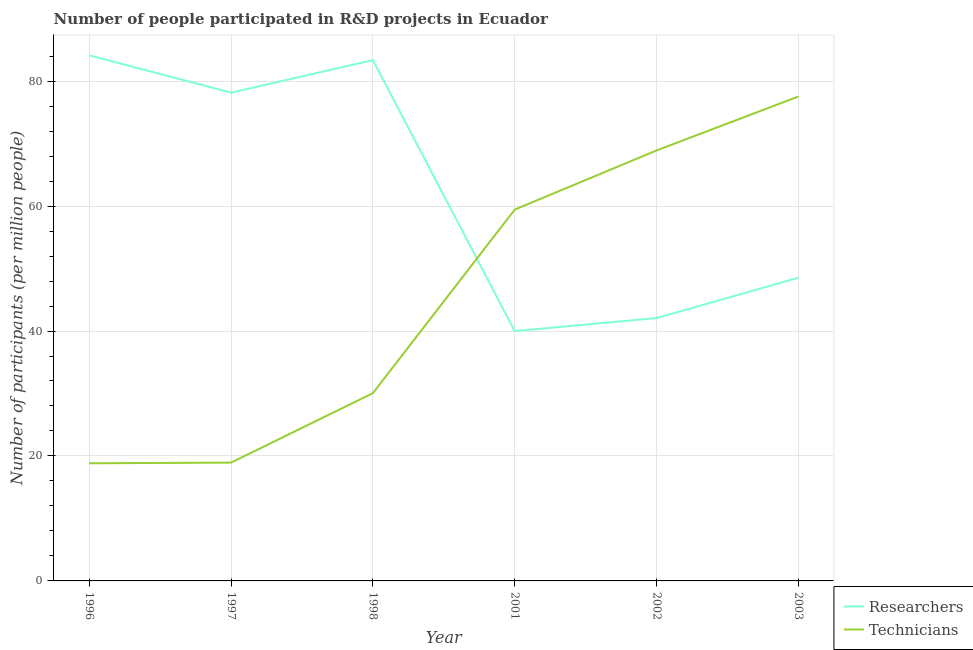How many different coloured lines are there?
Your response must be concise. 2. Does the line corresponding to number of technicians intersect with the line corresponding to number of researchers?
Provide a short and direct response. Yes. What is the number of technicians in 2001?
Ensure brevity in your answer.  59.44. Across all years, what is the maximum number of technicians?
Provide a succinct answer. 77.54. Across all years, what is the minimum number of technicians?
Offer a very short reply. 18.83. In which year was the number of researchers maximum?
Offer a terse response. 1996. In which year was the number of technicians minimum?
Make the answer very short. 1996. What is the total number of researchers in the graph?
Your response must be concise. 376.25. What is the difference between the number of researchers in 1998 and that in 2001?
Provide a succinct answer. 43.37. What is the difference between the number of technicians in 2002 and the number of researchers in 1998?
Your answer should be compact. -14.45. What is the average number of researchers per year?
Your answer should be compact. 62.71. In the year 1998, what is the difference between the number of researchers and number of technicians?
Offer a terse response. 53.31. What is the ratio of the number of technicians in 1996 to that in 2003?
Provide a succinct answer. 0.24. Is the number of technicians in 1996 less than that in 2003?
Offer a terse response. Yes. What is the difference between the highest and the second highest number of researchers?
Make the answer very short. 0.77. What is the difference between the highest and the lowest number of researchers?
Make the answer very short. 44.14. Does the number of researchers monotonically increase over the years?
Provide a short and direct response. No. How many lines are there?
Your answer should be very brief. 2. How many years are there in the graph?
Ensure brevity in your answer.  6. What is the difference between two consecutive major ticks on the Y-axis?
Offer a very short reply. 20. Are the values on the major ticks of Y-axis written in scientific E-notation?
Keep it short and to the point. No. Does the graph contain grids?
Provide a short and direct response. Yes. Where does the legend appear in the graph?
Ensure brevity in your answer.  Bottom right. How are the legend labels stacked?
Your response must be concise. Vertical. What is the title of the graph?
Provide a short and direct response. Number of people participated in R&D projects in Ecuador. What is the label or title of the Y-axis?
Make the answer very short. Number of participants (per million people). What is the Number of participants (per million people) in Researchers in 1996?
Ensure brevity in your answer.  84.14. What is the Number of participants (per million people) in Technicians in 1996?
Offer a terse response. 18.83. What is the Number of participants (per million people) of Researchers in 1997?
Keep it short and to the point. 78.16. What is the Number of participants (per million people) of Technicians in 1997?
Keep it short and to the point. 18.94. What is the Number of participants (per million people) of Researchers in 1998?
Ensure brevity in your answer.  83.36. What is the Number of participants (per million people) of Technicians in 1998?
Your answer should be very brief. 30.05. What is the Number of participants (per million people) in Researchers in 2001?
Provide a short and direct response. 39.99. What is the Number of participants (per million people) in Technicians in 2001?
Provide a short and direct response. 59.44. What is the Number of participants (per million people) in Researchers in 2002?
Your response must be concise. 42.07. What is the Number of participants (per million people) in Technicians in 2002?
Offer a terse response. 68.91. What is the Number of participants (per million people) in Researchers in 2003?
Make the answer very short. 48.53. What is the Number of participants (per million people) of Technicians in 2003?
Your answer should be very brief. 77.54. Across all years, what is the maximum Number of participants (per million people) of Researchers?
Offer a very short reply. 84.14. Across all years, what is the maximum Number of participants (per million people) of Technicians?
Provide a succinct answer. 77.54. Across all years, what is the minimum Number of participants (per million people) in Researchers?
Offer a very short reply. 39.99. Across all years, what is the minimum Number of participants (per million people) of Technicians?
Your answer should be compact. 18.83. What is the total Number of participants (per million people) of Researchers in the graph?
Offer a very short reply. 376.25. What is the total Number of participants (per million people) of Technicians in the graph?
Provide a short and direct response. 273.7. What is the difference between the Number of participants (per million people) in Researchers in 1996 and that in 1997?
Your answer should be very brief. 5.98. What is the difference between the Number of participants (per million people) in Technicians in 1996 and that in 1997?
Your answer should be compact. -0.11. What is the difference between the Number of participants (per million people) in Researchers in 1996 and that in 1998?
Your response must be concise. 0.77. What is the difference between the Number of participants (per million people) of Technicians in 1996 and that in 1998?
Your answer should be compact. -11.22. What is the difference between the Number of participants (per million people) of Researchers in 1996 and that in 2001?
Your answer should be compact. 44.14. What is the difference between the Number of participants (per million people) of Technicians in 1996 and that in 2001?
Ensure brevity in your answer.  -40.61. What is the difference between the Number of participants (per million people) in Researchers in 1996 and that in 2002?
Make the answer very short. 42.06. What is the difference between the Number of participants (per million people) in Technicians in 1996 and that in 2002?
Keep it short and to the point. -50.08. What is the difference between the Number of participants (per million people) in Researchers in 1996 and that in 2003?
Your answer should be compact. 35.6. What is the difference between the Number of participants (per million people) of Technicians in 1996 and that in 2003?
Provide a succinct answer. -58.71. What is the difference between the Number of participants (per million people) in Researchers in 1997 and that in 1998?
Ensure brevity in your answer.  -5.21. What is the difference between the Number of participants (per million people) in Technicians in 1997 and that in 1998?
Offer a terse response. -11.12. What is the difference between the Number of participants (per million people) in Researchers in 1997 and that in 2001?
Make the answer very short. 38.16. What is the difference between the Number of participants (per million people) in Technicians in 1997 and that in 2001?
Offer a very short reply. -40.5. What is the difference between the Number of participants (per million people) of Researchers in 1997 and that in 2002?
Ensure brevity in your answer.  36.08. What is the difference between the Number of participants (per million people) of Technicians in 1997 and that in 2002?
Offer a very short reply. -49.97. What is the difference between the Number of participants (per million people) of Researchers in 1997 and that in 2003?
Your response must be concise. 29.62. What is the difference between the Number of participants (per million people) of Technicians in 1997 and that in 2003?
Ensure brevity in your answer.  -58.6. What is the difference between the Number of participants (per million people) in Researchers in 1998 and that in 2001?
Offer a terse response. 43.37. What is the difference between the Number of participants (per million people) of Technicians in 1998 and that in 2001?
Make the answer very short. -29.38. What is the difference between the Number of participants (per million people) in Researchers in 1998 and that in 2002?
Make the answer very short. 41.29. What is the difference between the Number of participants (per million people) in Technicians in 1998 and that in 2002?
Offer a very short reply. -38.85. What is the difference between the Number of participants (per million people) of Researchers in 1998 and that in 2003?
Provide a short and direct response. 34.83. What is the difference between the Number of participants (per million people) of Technicians in 1998 and that in 2003?
Give a very brief answer. -47.49. What is the difference between the Number of participants (per million people) of Researchers in 2001 and that in 2002?
Ensure brevity in your answer.  -2.08. What is the difference between the Number of participants (per million people) in Technicians in 2001 and that in 2002?
Keep it short and to the point. -9.47. What is the difference between the Number of participants (per million people) of Researchers in 2001 and that in 2003?
Offer a terse response. -8.54. What is the difference between the Number of participants (per million people) of Technicians in 2001 and that in 2003?
Your response must be concise. -18.1. What is the difference between the Number of participants (per million people) of Researchers in 2002 and that in 2003?
Your answer should be compact. -6.46. What is the difference between the Number of participants (per million people) of Technicians in 2002 and that in 2003?
Provide a succinct answer. -8.63. What is the difference between the Number of participants (per million people) in Researchers in 1996 and the Number of participants (per million people) in Technicians in 1997?
Provide a succinct answer. 65.2. What is the difference between the Number of participants (per million people) in Researchers in 1996 and the Number of participants (per million people) in Technicians in 1998?
Give a very brief answer. 54.08. What is the difference between the Number of participants (per million people) of Researchers in 1996 and the Number of participants (per million people) of Technicians in 2001?
Your response must be concise. 24.7. What is the difference between the Number of participants (per million people) in Researchers in 1996 and the Number of participants (per million people) in Technicians in 2002?
Offer a terse response. 15.23. What is the difference between the Number of participants (per million people) in Researchers in 1996 and the Number of participants (per million people) in Technicians in 2003?
Offer a very short reply. 6.6. What is the difference between the Number of participants (per million people) in Researchers in 1997 and the Number of participants (per million people) in Technicians in 1998?
Keep it short and to the point. 48.1. What is the difference between the Number of participants (per million people) in Researchers in 1997 and the Number of participants (per million people) in Technicians in 2001?
Your answer should be very brief. 18.72. What is the difference between the Number of participants (per million people) in Researchers in 1997 and the Number of participants (per million people) in Technicians in 2002?
Give a very brief answer. 9.25. What is the difference between the Number of participants (per million people) of Researchers in 1997 and the Number of participants (per million people) of Technicians in 2003?
Your answer should be compact. 0.62. What is the difference between the Number of participants (per million people) in Researchers in 1998 and the Number of participants (per million people) in Technicians in 2001?
Your answer should be compact. 23.92. What is the difference between the Number of participants (per million people) in Researchers in 1998 and the Number of participants (per million people) in Technicians in 2002?
Provide a succinct answer. 14.45. What is the difference between the Number of participants (per million people) in Researchers in 1998 and the Number of participants (per million people) in Technicians in 2003?
Your answer should be very brief. 5.82. What is the difference between the Number of participants (per million people) in Researchers in 2001 and the Number of participants (per million people) in Technicians in 2002?
Your response must be concise. -28.92. What is the difference between the Number of participants (per million people) in Researchers in 2001 and the Number of participants (per million people) in Technicians in 2003?
Provide a short and direct response. -37.55. What is the difference between the Number of participants (per million people) in Researchers in 2002 and the Number of participants (per million people) in Technicians in 2003?
Offer a terse response. -35.47. What is the average Number of participants (per million people) of Researchers per year?
Give a very brief answer. 62.71. What is the average Number of participants (per million people) in Technicians per year?
Make the answer very short. 45.62. In the year 1996, what is the difference between the Number of participants (per million people) in Researchers and Number of participants (per million people) in Technicians?
Your response must be concise. 65.31. In the year 1997, what is the difference between the Number of participants (per million people) in Researchers and Number of participants (per million people) in Technicians?
Ensure brevity in your answer.  59.22. In the year 1998, what is the difference between the Number of participants (per million people) in Researchers and Number of participants (per million people) in Technicians?
Provide a short and direct response. 53.31. In the year 2001, what is the difference between the Number of participants (per million people) in Researchers and Number of participants (per million people) in Technicians?
Ensure brevity in your answer.  -19.45. In the year 2002, what is the difference between the Number of participants (per million people) in Researchers and Number of participants (per million people) in Technicians?
Ensure brevity in your answer.  -26.83. In the year 2003, what is the difference between the Number of participants (per million people) of Researchers and Number of participants (per million people) of Technicians?
Your answer should be compact. -29.01. What is the ratio of the Number of participants (per million people) of Researchers in 1996 to that in 1997?
Offer a terse response. 1.08. What is the ratio of the Number of participants (per million people) of Technicians in 1996 to that in 1997?
Offer a terse response. 0.99. What is the ratio of the Number of participants (per million people) of Researchers in 1996 to that in 1998?
Offer a terse response. 1.01. What is the ratio of the Number of participants (per million people) in Technicians in 1996 to that in 1998?
Offer a very short reply. 0.63. What is the ratio of the Number of participants (per million people) in Researchers in 1996 to that in 2001?
Offer a terse response. 2.1. What is the ratio of the Number of participants (per million people) in Technicians in 1996 to that in 2001?
Provide a succinct answer. 0.32. What is the ratio of the Number of participants (per million people) in Researchers in 1996 to that in 2002?
Your answer should be very brief. 2. What is the ratio of the Number of participants (per million people) of Technicians in 1996 to that in 2002?
Offer a terse response. 0.27. What is the ratio of the Number of participants (per million people) in Researchers in 1996 to that in 2003?
Your answer should be compact. 1.73. What is the ratio of the Number of participants (per million people) in Technicians in 1996 to that in 2003?
Provide a succinct answer. 0.24. What is the ratio of the Number of participants (per million people) of Technicians in 1997 to that in 1998?
Make the answer very short. 0.63. What is the ratio of the Number of participants (per million people) in Researchers in 1997 to that in 2001?
Offer a very short reply. 1.95. What is the ratio of the Number of participants (per million people) in Technicians in 1997 to that in 2001?
Provide a short and direct response. 0.32. What is the ratio of the Number of participants (per million people) in Researchers in 1997 to that in 2002?
Your answer should be very brief. 1.86. What is the ratio of the Number of participants (per million people) of Technicians in 1997 to that in 2002?
Offer a very short reply. 0.27. What is the ratio of the Number of participants (per million people) of Researchers in 1997 to that in 2003?
Your response must be concise. 1.61. What is the ratio of the Number of participants (per million people) in Technicians in 1997 to that in 2003?
Offer a terse response. 0.24. What is the ratio of the Number of participants (per million people) of Researchers in 1998 to that in 2001?
Your answer should be compact. 2.08. What is the ratio of the Number of participants (per million people) of Technicians in 1998 to that in 2001?
Provide a succinct answer. 0.51. What is the ratio of the Number of participants (per million people) of Researchers in 1998 to that in 2002?
Provide a short and direct response. 1.98. What is the ratio of the Number of participants (per million people) of Technicians in 1998 to that in 2002?
Give a very brief answer. 0.44. What is the ratio of the Number of participants (per million people) in Researchers in 1998 to that in 2003?
Your answer should be very brief. 1.72. What is the ratio of the Number of participants (per million people) of Technicians in 1998 to that in 2003?
Give a very brief answer. 0.39. What is the ratio of the Number of participants (per million people) in Researchers in 2001 to that in 2002?
Keep it short and to the point. 0.95. What is the ratio of the Number of participants (per million people) in Technicians in 2001 to that in 2002?
Offer a very short reply. 0.86. What is the ratio of the Number of participants (per million people) in Researchers in 2001 to that in 2003?
Your response must be concise. 0.82. What is the ratio of the Number of participants (per million people) in Technicians in 2001 to that in 2003?
Ensure brevity in your answer.  0.77. What is the ratio of the Number of participants (per million people) in Researchers in 2002 to that in 2003?
Your answer should be compact. 0.87. What is the ratio of the Number of participants (per million people) in Technicians in 2002 to that in 2003?
Provide a succinct answer. 0.89. What is the difference between the highest and the second highest Number of participants (per million people) in Researchers?
Offer a terse response. 0.77. What is the difference between the highest and the second highest Number of participants (per million people) of Technicians?
Offer a terse response. 8.63. What is the difference between the highest and the lowest Number of participants (per million people) in Researchers?
Provide a short and direct response. 44.14. What is the difference between the highest and the lowest Number of participants (per million people) in Technicians?
Provide a short and direct response. 58.71. 